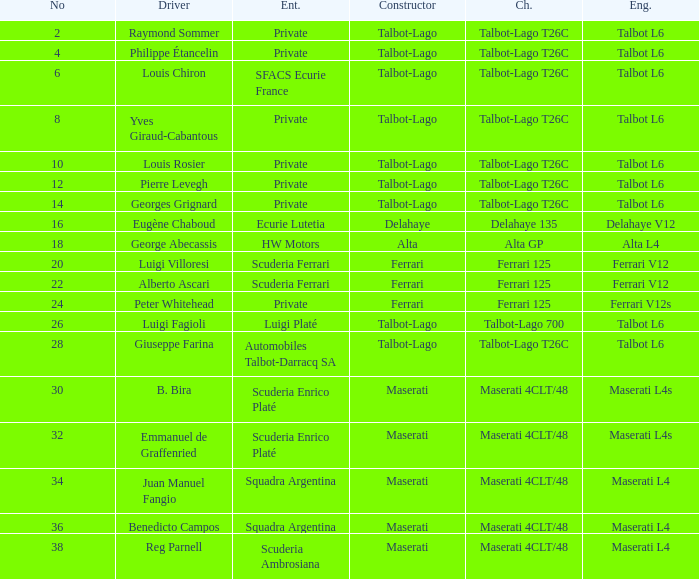Name the chassis for sfacs ecurie france Talbot-Lago T26C. 